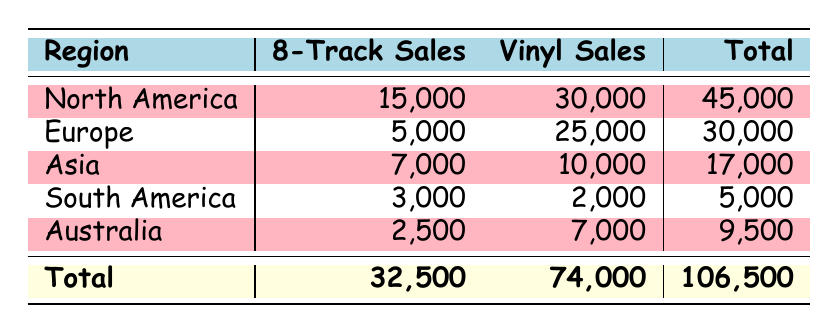What region has the highest 8-track sales? The highest value in the '8-Track Sales' column is 15,000, which corresponds to North America.
Answer: North America What is the total 8-track sales across all regions? To find the total 8-track sales, sum the values in the '8-Track Sales' column: 15,000 + 5,000 + 7,000 + 3,000 + 2,500 = 32,500.
Answer: 32,500 Which region has more vinyl sales than 8-track sales? By comparing each region's vinyl sales to their 8-track sales in the table, North America, Europe, Asia, and Australia all have higher vinyl sales. South America has fewer vinyl sales than 8-track sales.
Answer: North America, Europe, Asia, Australia Is South America the only region with more 8-track sales than vinyl sales? Upon reviewing the table, South America has 3,000 in 8-track sales and only 2,000 in vinyl sales, making it the only region where 8-track sales exceed vinyl sales.
Answer: Yes What is the average number of vinyl sales among the five regions? To calculate the average, sum the vinyl sales: 30,000 + 25,000 + 10,000 + 2,000 + 7,000 = 74,000. Then, divide by the number of regions, which is 5: 74,000 / 5 = 14,800.
Answer: 14,800 Which region contributes the least to the total sales, and what is the total sales for that region? By examining the total sales, South America totals only 5,000, which is the smallest figure among all regions.
Answer: South America, 5,000 What are the total sales in North America compared to South America? To compare, add together the 8-track and vinyl sales in both regions: North America has 15,000 + 30,000 = 45,000, while South America has 3,000 + 2,000 = 5,000. North America has significantly higher total sales.
Answer: North America has higher total sales Which region has the second highest number of 8-track sales? The second highest figure for 8-track sales is 7,000 from Asia, just below North America's 15,000.
Answer: Asia 